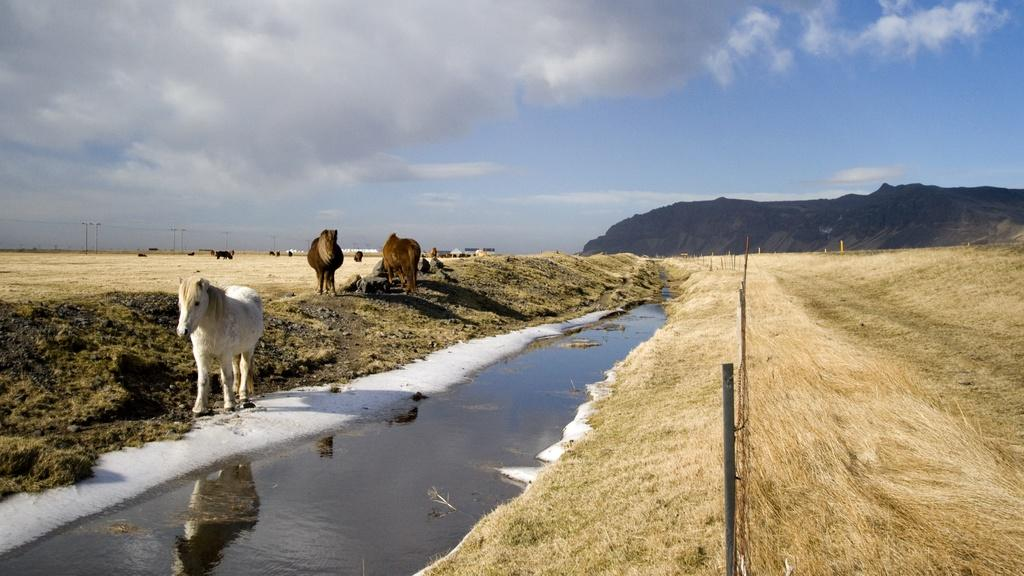What can be seen on the left side of the image? There is a white area on the left side of the image. What animals are present in the image? There are two brown horses in the image. What natural element is visible in the image? There is water visible in the image. What type of vegetation is present can be seen in the image? There is dried grass in the image. What is the condition of the sky in the image? The sky is cloudy in the image. Where is the mother of the horses in the image? There is no mother of the horses present in the image. What type of club can be seen in the image? There is no club present in the image. 